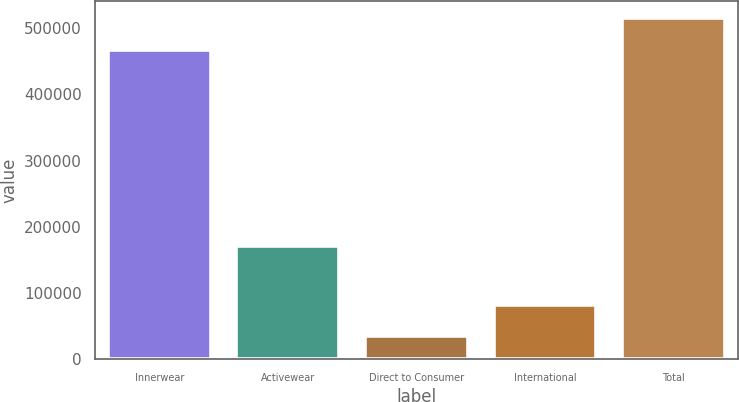Convert chart. <chart><loc_0><loc_0><loc_500><loc_500><bar_chart><fcel>Innerwear<fcel>Activewear<fcel>Direct to Consumer<fcel>International<fcel>Total<nl><fcel>467398<fcel>170749<fcel>34737<fcel>82781.9<fcel>515443<nl></chart> 